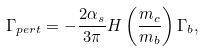Convert formula to latex. <formula><loc_0><loc_0><loc_500><loc_500>\Gamma _ { p e r t } = - \frac { 2 \alpha _ { s } } { 3 \pi } H \left ( \frac { m _ { c } } { m _ { b } } \right ) \Gamma _ { b } ,</formula> 